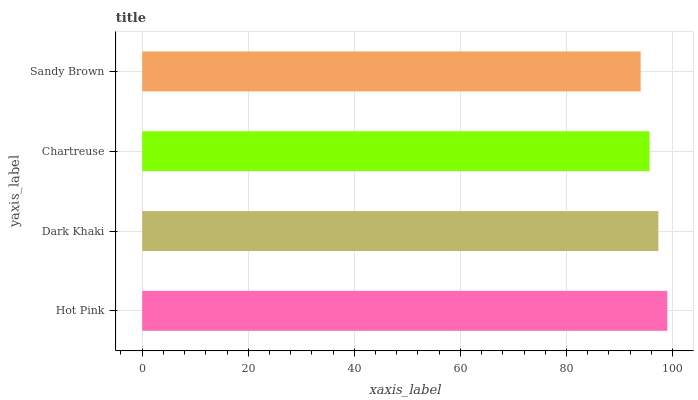Is Sandy Brown the minimum?
Answer yes or no. Yes. Is Hot Pink the maximum?
Answer yes or no. Yes. Is Dark Khaki the minimum?
Answer yes or no. No. Is Dark Khaki the maximum?
Answer yes or no. No. Is Hot Pink greater than Dark Khaki?
Answer yes or no. Yes. Is Dark Khaki less than Hot Pink?
Answer yes or no. Yes. Is Dark Khaki greater than Hot Pink?
Answer yes or no. No. Is Hot Pink less than Dark Khaki?
Answer yes or no. No. Is Dark Khaki the high median?
Answer yes or no. Yes. Is Chartreuse the low median?
Answer yes or no. Yes. Is Chartreuse the high median?
Answer yes or no. No. Is Hot Pink the low median?
Answer yes or no. No. 